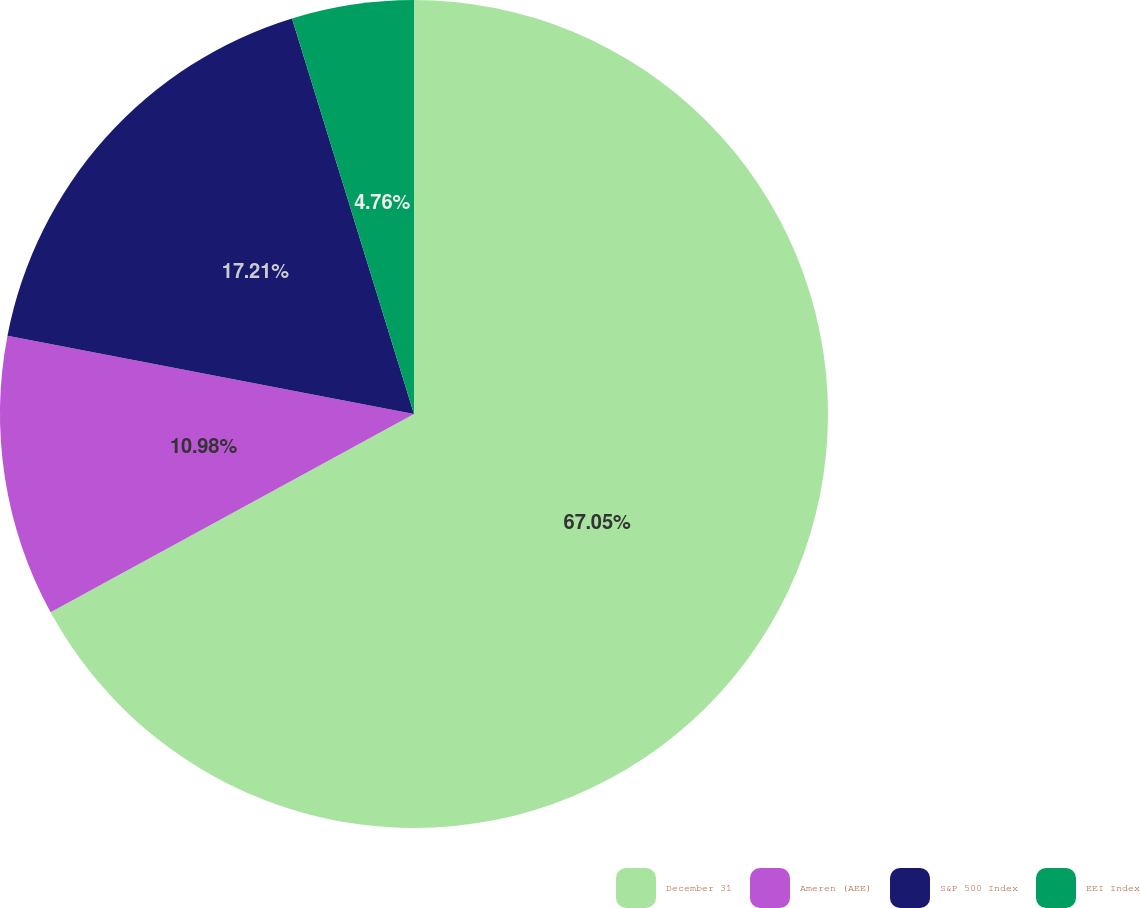Convert chart. <chart><loc_0><loc_0><loc_500><loc_500><pie_chart><fcel>December 31<fcel>Ameren (AEE)<fcel>S&P 500 Index<fcel>EEI Index<nl><fcel>67.05%<fcel>10.98%<fcel>17.21%<fcel>4.76%<nl></chart> 